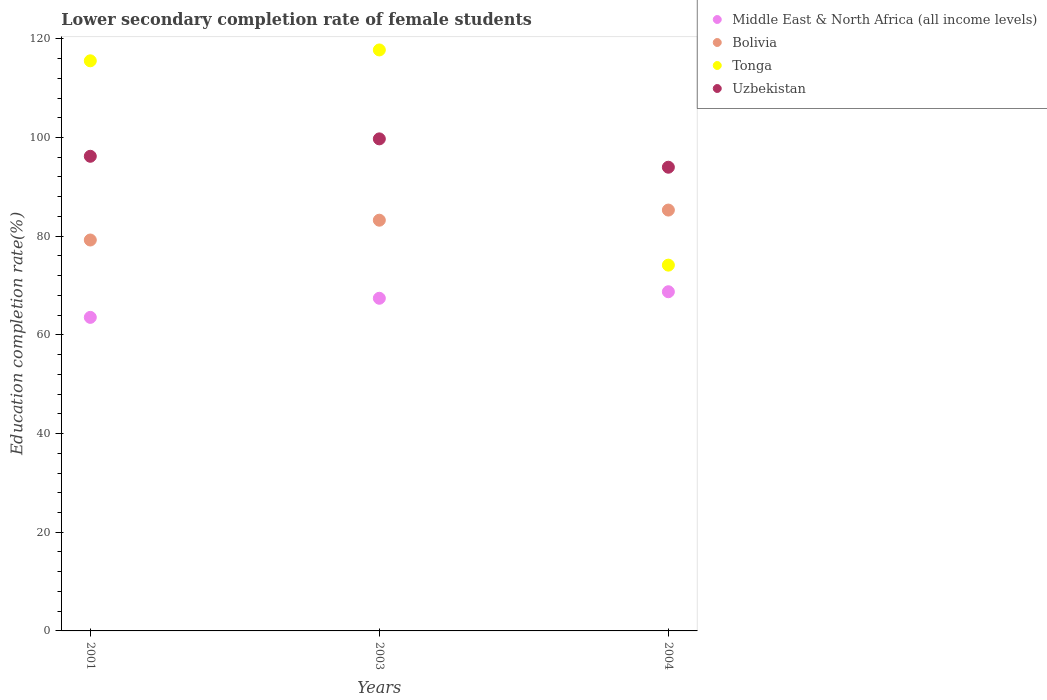What is the lower secondary completion rate of female students in Bolivia in 2003?
Keep it short and to the point. 83.24. Across all years, what is the maximum lower secondary completion rate of female students in Middle East & North Africa (all income levels)?
Ensure brevity in your answer.  68.74. Across all years, what is the minimum lower secondary completion rate of female students in Uzbekistan?
Your answer should be compact. 93.98. What is the total lower secondary completion rate of female students in Middle East & North Africa (all income levels) in the graph?
Your answer should be very brief. 199.71. What is the difference between the lower secondary completion rate of female students in Middle East & North Africa (all income levels) in 2001 and that in 2003?
Your response must be concise. -3.87. What is the difference between the lower secondary completion rate of female students in Tonga in 2004 and the lower secondary completion rate of female students in Middle East & North Africa (all income levels) in 2001?
Make the answer very short. 10.59. What is the average lower secondary completion rate of female students in Uzbekistan per year?
Provide a succinct answer. 96.63. In the year 2003, what is the difference between the lower secondary completion rate of female students in Bolivia and lower secondary completion rate of female students in Uzbekistan?
Your answer should be very brief. -16.48. What is the ratio of the lower secondary completion rate of female students in Uzbekistan in 2001 to that in 2003?
Ensure brevity in your answer.  0.96. Is the lower secondary completion rate of female students in Uzbekistan in 2001 less than that in 2003?
Your answer should be compact. Yes. Is the difference between the lower secondary completion rate of female students in Bolivia in 2001 and 2004 greater than the difference between the lower secondary completion rate of female students in Uzbekistan in 2001 and 2004?
Your answer should be very brief. No. What is the difference between the highest and the second highest lower secondary completion rate of female students in Tonga?
Give a very brief answer. 2.2. What is the difference between the highest and the lowest lower secondary completion rate of female students in Uzbekistan?
Give a very brief answer. 5.74. Is it the case that in every year, the sum of the lower secondary completion rate of female students in Middle East & North Africa (all income levels) and lower secondary completion rate of female students in Tonga  is greater than the sum of lower secondary completion rate of female students in Bolivia and lower secondary completion rate of female students in Uzbekistan?
Provide a succinct answer. No. How many dotlines are there?
Keep it short and to the point. 4. How many years are there in the graph?
Offer a terse response. 3. What is the difference between two consecutive major ticks on the Y-axis?
Offer a very short reply. 20. Are the values on the major ticks of Y-axis written in scientific E-notation?
Provide a short and direct response. No. Where does the legend appear in the graph?
Your answer should be compact. Top right. How many legend labels are there?
Your answer should be very brief. 4. What is the title of the graph?
Ensure brevity in your answer.  Lower secondary completion rate of female students. Does "Sub-Saharan Africa (all income levels)" appear as one of the legend labels in the graph?
Give a very brief answer. No. What is the label or title of the X-axis?
Provide a short and direct response. Years. What is the label or title of the Y-axis?
Make the answer very short. Education completion rate(%). What is the Education completion rate(%) in Middle East & North Africa (all income levels) in 2001?
Ensure brevity in your answer.  63.55. What is the Education completion rate(%) of Bolivia in 2001?
Your answer should be very brief. 79.23. What is the Education completion rate(%) of Tonga in 2001?
Offer a terse response. 115.54. What is the Education completion rate(%) of Uzbekistan in 2001?
Offer a very short reply. 96.2. What is the Education completion rate(%) of Middle East & North Africa (all income levels) in 2003?
Offer a terse response. 67.42. What is the Education completion rate(%) in Bolivia in 2003?
Your response must be concise. 83.24. What is the Education completion rate(%) in Tonga in 2003?
Provide a succinct answer. 117.75. What is the Education completion rate(%) of Uzbekistan in 2003?
Your answer should be compact. 99.72. What is the Education completion rate(%) in Middle East & North Africa (all income levels) in 2004?
Your answer should be compact. 68.74. What is the Education completion rate(%) of Bolivia in 2004?
Your response must be concise. 85.29. What is the Education completion rate(%) of Tonga in 2004?
Provide a succinct answer. 74.13. What is the Education completion rate(%) of Uzbekistan in 2004?
Your answer should be compact. 93.98. Across all years, what is the maximum Education completion rate(%) in Middle East & North Africa (all income levels)?
Your response must be concise. 68.74. Across all years, what is the maximum Education completion rate(%) of Bolivia?
Offer a terse response. 85.29. Across all years, what is the maximum Education completion rate(%) in Tonga?
Keep it short and to the point. 117.75. Across all years, what is the maximum Education completion rate(%) of Uzbekistan?
Ensure brevity in your answer.  99.72. Across all years, what is the minimum Education completion rate(%) in Middle East & North Africa (all income levels)?
Your answer should be very brief. 63.55. Across all years, what is the minimum Education completion rate(%) in Bolivia?
Your response must be concise. 79.23. Across all years, what is the minimum Education completion rate(%) of Tonga?
Offer a very short reply. 74.13. Across all years, what is the minimum Education completion rate(%) in Uzbekistan?
Provide a short and direct response. 93.98. What is the total Education completion rate(%) of Middle East & North Africa (all income levels) in the graph?
Offer a very short reply. 199.71. What is the total Education completion rate(%) of Bolivia in the graph?
Offer a terse response. 247.76. What is the total Education completion rate(%) of Tonga in the graph?
Provide a succinct answer. 307.43. What is the total Education completion rate(%) in Uzbekistan in the graph?
Keep it short and to the point. 289.9. What is the difference between the Education completion rate(%) of Middle East & North Africa (all income levels) in 2001 and that in 2003?
Your answer should be compact. -3.87. What is the difference between the Education completion rate(%) of Bolivia in 2001 and that in 2003?
Ensure brevity in your answer.  -4.01. What is the difference between the Education completion rate(%) in Tonga in 2001 and that in 2003?
Your answer should be compact. -2.2. What is the difference between the Education completion rate(%) of Uzbekistan in 2001 and that in 2003?
Make the answer very short. -3.53. What is the difference between the Education completion rate(%) of Middle East & North Africa (all income levels) in 2001 and that in 2004?
Your answer should be very brief. -5.19. What is the difference between the Education completion rate(%) in Bolivia in 2001 and that in 2004?
Your answer should be very brief. -6.07. What is the difference between the Education completion rate(%) of Tonga in 2001 and that in 2004?
Your answer should be compact. 41.41. What is the difference between the Education completion rate(%) of Uzbekistan in 2001 and that in 2004?
Provide a succinct answer. 2.22. What is the difference between the Education completion rate(%) in Middle East & North Africa (all income levels) in 2003 and that in 2004?
Give a very brief answer. -1.32. What is the difference between the Education completion rate(%) of Bolivia in 2003 and that in 2004?
Your answer should be compact. -2.05. What is the difference between the Education completion rate(%) of Tonga in 2003 and that in 2004?
Keep it short and to the point. 43.61. What is the difference between the Education completion rate(%) of Uzbekistan in 2003 and that in 2004?
Offer a terse response. 5.74. What is the difference between the Education completion rate(%) in Middle East & North Africa (all income levels) in 2001 and the Education completion rate(%) in Bolivia in 2003?
Your answer should be very brief. -19.69. What is the difference between the Education completion rate(%) in Middle East & North Africa (all income levels) in 2001 and the Education completion rate(%) in Tonga in 2003?
Your response must be concise. -54.2. What is the difference between the Education completion rate(%) in Middle East & North Africa (all income levels) in 2001 and the Education completion rate(%) in Uzbekistan in 2003?
Offer a terse response. -36.18. What is the difference between the Education completion rate(%) of Bolivia in 2001 and the Education completion rate(%) of Tonga in 2003?
Your response must be concise. -38.52. What is the difference between the Education completion rate(%) of Bolivia in 2001 and the Education completion rate(%) of Uzbekistan in 2003?
Keep it short and to the point. -20.5. What is the difference between the Education completion rate(%) of Tonga in 2001 and the Education completion rate(%) of Uzbekistan in 2003?
Provide a short and direct response. 15.82. What is the difference between the Education completion rate(%) in Middle East & North Africa (all income levels) in 2001 and the Education completion rate(%) in Bolivia in 2004?
Your response must be concise. -21.75. What is the difference between the Education completion rate(%) in Middle East & North Africa (all income levels) in 2001 and the Education completion rate(%) in Tonga in 2004?
Offer a very short reply. -10.59. What is the difference between the Education completion rate(%) in Middle East & North Africa (all income levels) in 2001 and the Education completion rate(%) in Uzbekistan in 2004?
Offer a very short reply. -30.43. What is the difference between the Education completion rate(%) in Bolivia in 2001 and the Education completion rate(%) in Tonga in 2004?
Provide a succinct answer. 5.09. What is the difference between the Education completion rate(%) in Bolivia in 2001 and the Education completion rate(%) in Uzbekistan in 2004?
Make the answer very short. -14.75. What is the difference between the Education completion rate(%) in Tonga in 2001 and the Education completion rate(%) in Uzbekistan in 2004?
Give a very brief answer. 21.57. What is the difference between the Education completion rate(%) of Middle East & North Africa (all income levels) in 2003 and the Education completion rate(%) of Bolivia in 2004?
Give a very brief answer. -17.87. What is the difference between the Education completion rate(%) in Middle East & North Africa (all income levels) in 2003 and the Education completion rate(%) in Tonga in 2004?
Your answer should be compact. -6.72. What is the difference between the Education completion rate(%) in Middle East & North Africa (all income levels) in 2003 and the Education completion rate(%) in Uzbekistan in 2004?
Your response must be concise. -26.56. What is the difference between the Education completion rate(%) of Bolivia in 2003 and the Education completion rate(%) of Tonga in 2004?
Give a very brief answer. 9.11. What is the difference between the Education completion rate(%) of Bolivia in 2003 and the Education completion rate(%) of Uzbekistan in 2004?
Make the answer very short. -10.74. What is the difference between the Education completion rate(%) of Tonga in 2003 and the Education completion rate(%) of Uzbekistan in 2004?
Offer a terse response. 23.77. What is the average Education completion rate(%) of Middle East & North Africa (all income levels) per year?
Your response must be concise. 66.57. What is the average Education completion rate(%) in Bolivia per year?
Give a very brief answer. 82.59. What is the average Education completion rate(%) of Tonga per year?
Offer a terse response. 102.48. What is the average Education completion rate(%) of Uzbekistan per year?
Provide a short and direct response. 96.63. In the year 2001, what is the difference between the Education completion rate(%) in Middle East & North Africa (all income levels) and Education completion rate(%) in Bolivia?
Offer a very short reply. -15.68. In the year 2001, what is the difference between the Education completion rate(%) of Middle East & North Africa (all income levels) and Education completion rate(%) of Tonga?
Provide a short and direct response. -52. In the year 2001, what is the difference between the Education completion rate(%) in Middle East & North Africa (all income levels) and Education completion rate(%) in Uzbekistan?
Provide a succinct answer. -32.65. In the year 2001, what is the difference between the Education completion rate(%) of Bolivia and Education completion rate(%) of Tonga?
Your response must be concise. -36.32. In the year 2001, what is the difference between the Education completion rate(%) in Bolivia and Education completion rate(%) in Uzbekistan?
Keep it short and to the point. -16.97. In the year 2001, what is the difference between the Education completion rate(%) in Tonga and Education completion rate(%) in Uzbekistan?
Make the answer very short. 19.35. In the year 2003, what is the difference between the Education completion rate(%) in Middle East & North Africa (all income levels) and Education completion rate(%) in Bolivia?
Provide a short and direct response. -15.82. In the year 2003, what is the difference between the Education completion rate(%) in Middle East & North Africa (all income levels) and Education completion rate(%) in Tonga?
Keep it short and to the point. -50.33. In the year 2003, what is the difference between the Education completion rate(%) in Middle East & North Africa (all income levels) and Education completion rate(%) in Uzbekistan?
Give a very brief answer. -32.3. In the year 2003, what is the difference between the Education completion rate(%) in Bolivia and Education completion rate(%) in Tonga?
Provide a succinct answer. -34.51. In the year 2003, what is the difference between the Education completion rate(%) in Bolivia and Education completion rate(%) in Uzbekistan?
Ensure brevity in your answer.  -16.48. In the year 2003, what is the difference between the Education completion rate(%) of Tonga and Education completion rate(%) of Uzbekistan?
Offer a terse response. 18.02. In the year 2004, what is the difference between the Education completion rate(%) of Middle East & North Africa (all income levels) and Education completion rate(%) of Bolivia?
Provide a succinct answer. -16.55. In the year 2004, what is the difference between the Education completion rate(%) of Middle East & North Africa (all income levels) and Education completion rate(%) of Tonga?
Give a very brief answer. -5.39. In the year 2004, what is the difference between the Education completion rate(%) of Middle East & North Africa (all income levels) and Education completion rate(%) of Uzbekistan?
Keep it short and to the point. -25.24. In the year 2004, what is the difference between the Education completion rate(%) of Bolivia and Education completion rate(%) of Tonga?
Offer a terse response. 11.16. In the year 2004, what is the difference between the Education completion rate(%) of Bolivia and Education completion rate(%) of Uzbekistan?
Ensure brevity in your answer.  -8.69. In the year 2004, what is the difference between the Education completion rate(%) of Tonga and Education completion rate(%) of Uzbekistan?
Ensure brevity in your answer.  -19.84. What is the ratio of the Education completion rate(%) in Middle East & North Africa (all income levels) in 2001 to that in 2003?
Offer a terse response. 0.94. What is the ratio of the Education completion rate(%) in Bolivia in 2001 to that in 2003?
Your answer should be compact. 0.95. What is the ratio of the Education completion rate(%) in Tonga in 2001 to that in 2003?
Ensure brevity in your answer.  0.98. What is the ratio of the Education completion rate(%) in Uzbekistan in 2001 to that in 2003?
Your answer should be very brief. 0.96. What is the ratio of the Education completion rate(%) in Middle East & North Africa (all income levels) in 2001 to that in 2004?
Make the answer very short. 0.92. What is the ratio of the Education completion rate(%) in Bolivia in 2001 to that in 2004?
Provide a short and direct response. 0.93. What is the ratio of the Education completion rate(%) in Tonga in 2001 to that in 2004?
Ensure brevity in your answer.  1.56. What is the ratio of the Education completion rate(%) of Uzbekistan in 2001 to that in 2004?
Provide a short and direct response. 1.02. What is the ratio of the Education completion rate(%) of Middle East & North Africa (all income levels) in 2003 to that in 2004?
Your answer should be compact. 0.98. What is the ratio of the Education completion rate(%) in Bolivia in 2003 to that in 2004?
Keep it short and to the point. 0.98. What is the ratio of the Education completion rate(%) of Tonga in 2003 to that in 2004?
Offer a very short reply. 1.59. What is the ratio of the Education completion rate(%) of Uzbekistan in 2003 to that in 2004?
Keep it short and to the point. 1.06. What is the difference between the highest and the second highest Education completion rate(%) of Middle East & North Africa (all income levels)?
Offer a terse response. 1.32. What is the difference between the highest and the second highest Education completion rate(%) of Bolivia?
Offer a very short reply. 2.05. What is the difference between the highest and the second highest Education completion rate(%) of Tonga?
Ensure brevity in your answer.  2.2. What is the difference between the highest and the second highest Education completion rate(%) of Uzbekistan?
Make the answer very short. 3.53. What is the difference between the highest and the lowest Education completion rate(%) of Middle East & North Africa (all income levels)?
Your answer should be very brief. 5.19. What is the difference between the highest and the lowest Education completion rate(%) in Bolivia?
Make the answer very short. 6.07. What is the difference between the highest and the lowest Education completion rate(%) in Tonga?
Offer a terse response. 43.61. What is the difference between the highest and the lowest Education completion rate(%) of Uzbekistan?
Your response must be concise. 5.74. 